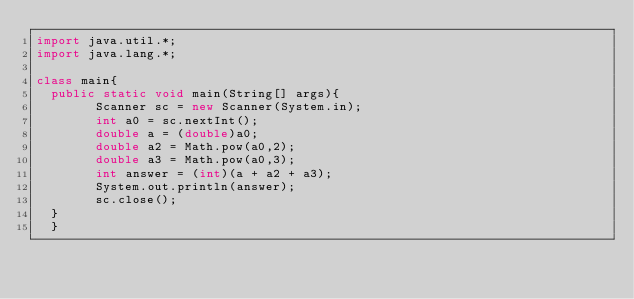<code> <loc_0><loc_0><loc_500><loc_500><_Java_>import java.util.*;
import java.lang.*;

class main{
  public static void main(String[] args){
    	Scanner sc = new Scanner(System.in);
	    int a0 = sc.nextInt();
	    double a = (double)a0;
	    double a2 = Math.pow(a0,2);
	    double a3 = Math.pow(a0,3);
	    int answer = (int)(a + a2 + a3);
	    System.out.println(answer);	    
	    sc.close();
  }
  }</code> 